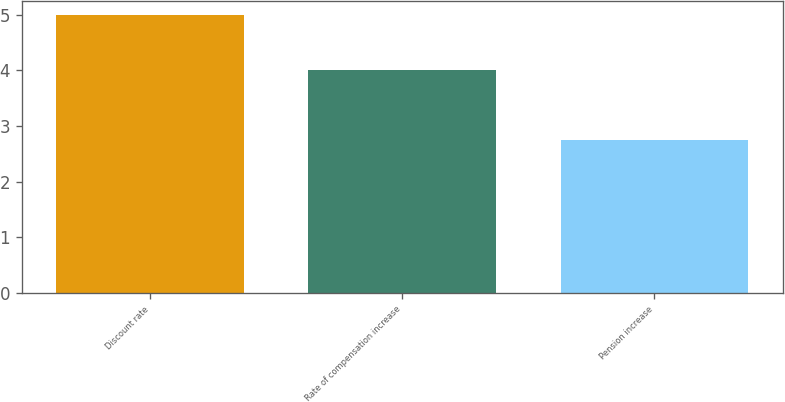Convert chart. <chart><loc_0><loc_0><loc_500><loc_500><bar_chart><fcel>Discount rate<fcel>Rate of compensation increase<fcel>Pension increase<nl><fcel>5<fcel>4<fcel>2.75<nl></chart> 